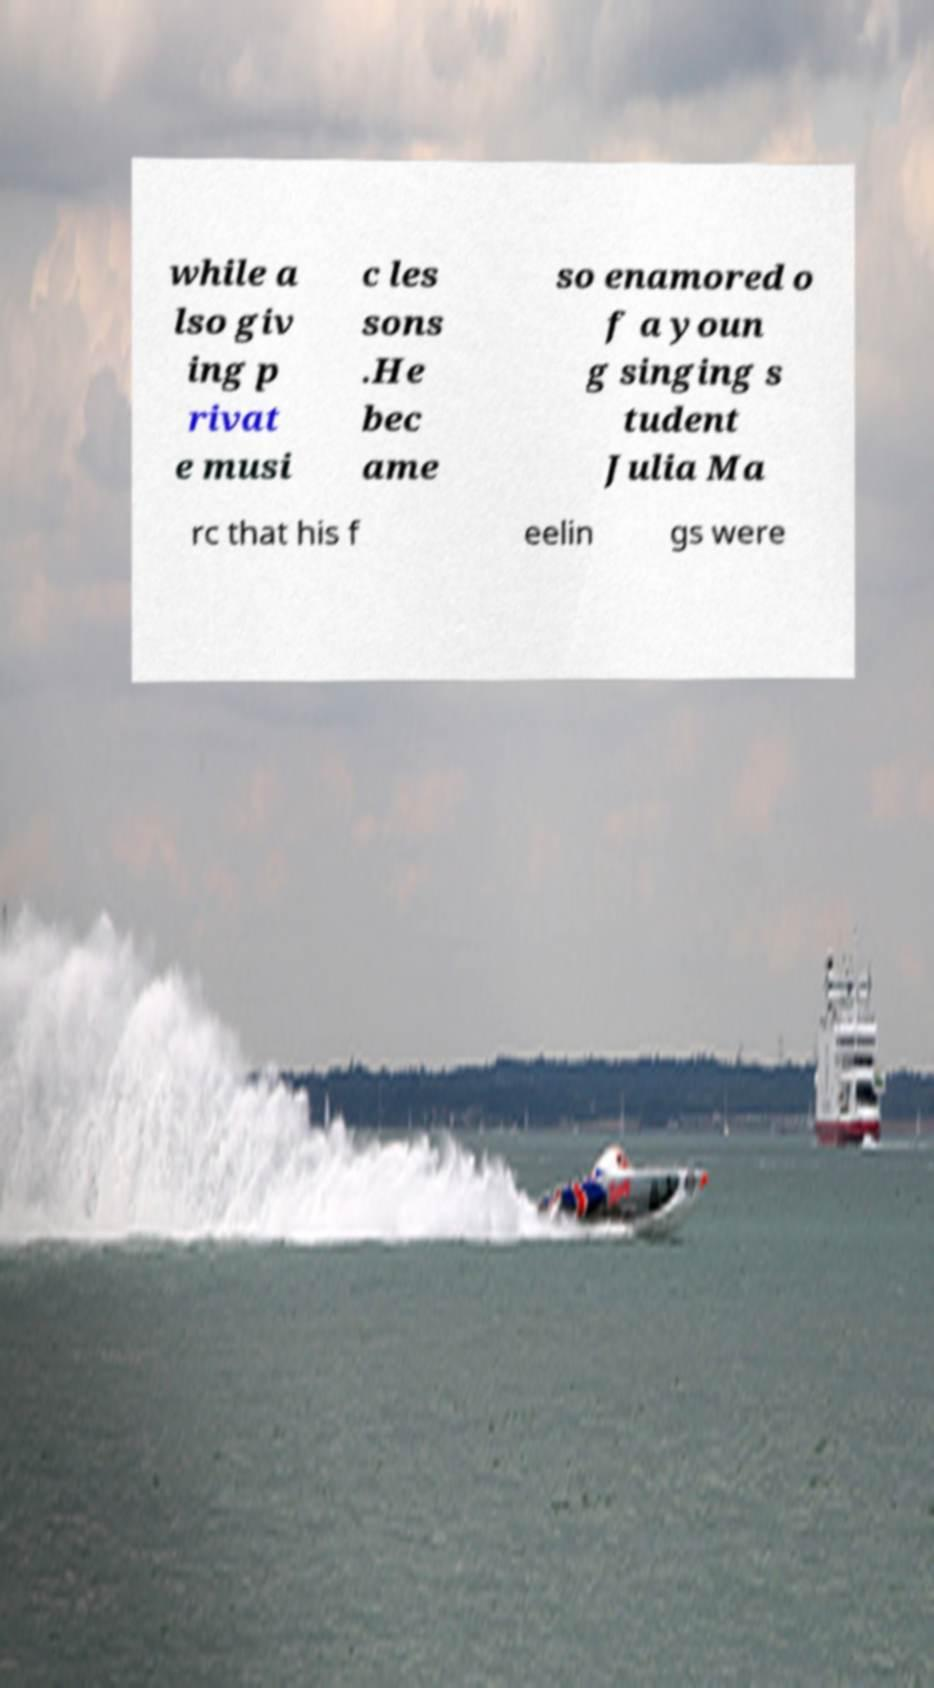I need the written content from this picture converted into text. Can you do that? while a lso giv ing p rivat e musi c les sons .He bec ame so enamored o f a youn g singing s tudent Julia Ma rc that his f eelin gs were 